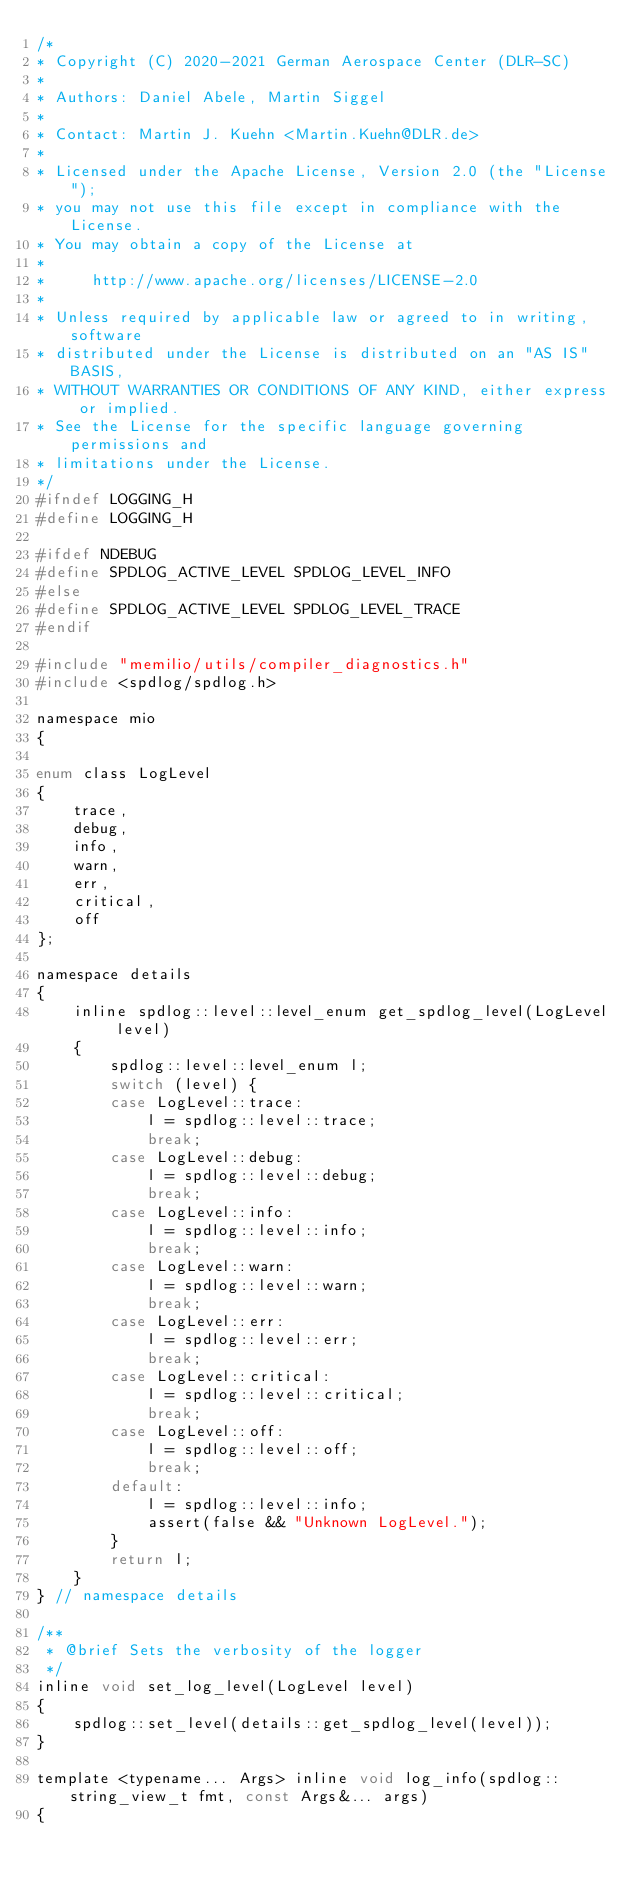Convert code to text. <code><loc_0><loc_0><loc_500><loc_500><_C_>/* 
* Copyright (C) 2020-2021 German Aerospace Center (DLR-SC)
*
* Authors: Daniel Abele, Martin Siggel
*
* Contact: Martin J. Kuehn <Martin.Kuehn@DLR.de>
*
* Licensed under the Apache License, Version 2.0 (the "License");
* you may not use this file except in compliance with the License.
* You may obtain a copy of the License at
*
*     http://www.apache.org/licenses/LICENSE-2.0
*
* Unless required by applicable law or agreed to in writing, software
* distributed under the License is distributed on an "AS IS" BASIS,
* WITHOUT WARRANTIES OR CONDITIONS OF ANY KIND, either express or implied.
* See the License for the specific language governing permissions and
* limitations under the License.
*/
#ifndef LOGGING_H
#define LOGGING_H

#ifdef NDEBUG
#define SPDLOG_ACTIVE_LEVEL SPDLOG_LEVEL_INFO
#else
#define SPDLOG_ACTIVE_LEVEL SPDLOG_LEVEL_TRACE
#endif

#include "memilio/utils/compiler_diagnostics.h"
#include <spdlog/spdlog.h>

namespace mio
{

enum class LogLevel
{
    trace,
    debug,
    info,
    warn,
    err,
    critical,
    off
};

namespace details
{
    inline spdlog::level::level_enum get_spdlog_level(LogLevel level)
    {
        spdlog::level::level_enum l;
        switch (level) {
        case LogLevel::trace:
            l = spdlog::level::trace;
            break;
        case LogLevel::debug:
            l = spdlog::level::debug;
            break;
        case LogLevel::info:
            l = spdlog::level::info;
            break;
        case LogLevel::warn:
            l = spdlog::level::warn;
            break;
        case LogLevel::err:
            l = spdlog::level::err;
            break;
        case LogLevel::critical:
            l = spdlog::level::critical;
            break;
        case LogLevel::off:
            l = spdlog::level::off;
            break;
        default:
            l = spdlog::level::info;
            assert(false && "Unknown LogLevel.");
        }
        return l;
    }
} // namespace details

/**
 * @brief Sets the verbosity of the logger
 */
inline void set_log_level(LogLevel level)
{
    spdlog::set_level(details::get_spdlog_level(level));
}

template <typename... Args> inline void log_info(spdlog::string_view_t fmt, const Args&... args)
{</code> 